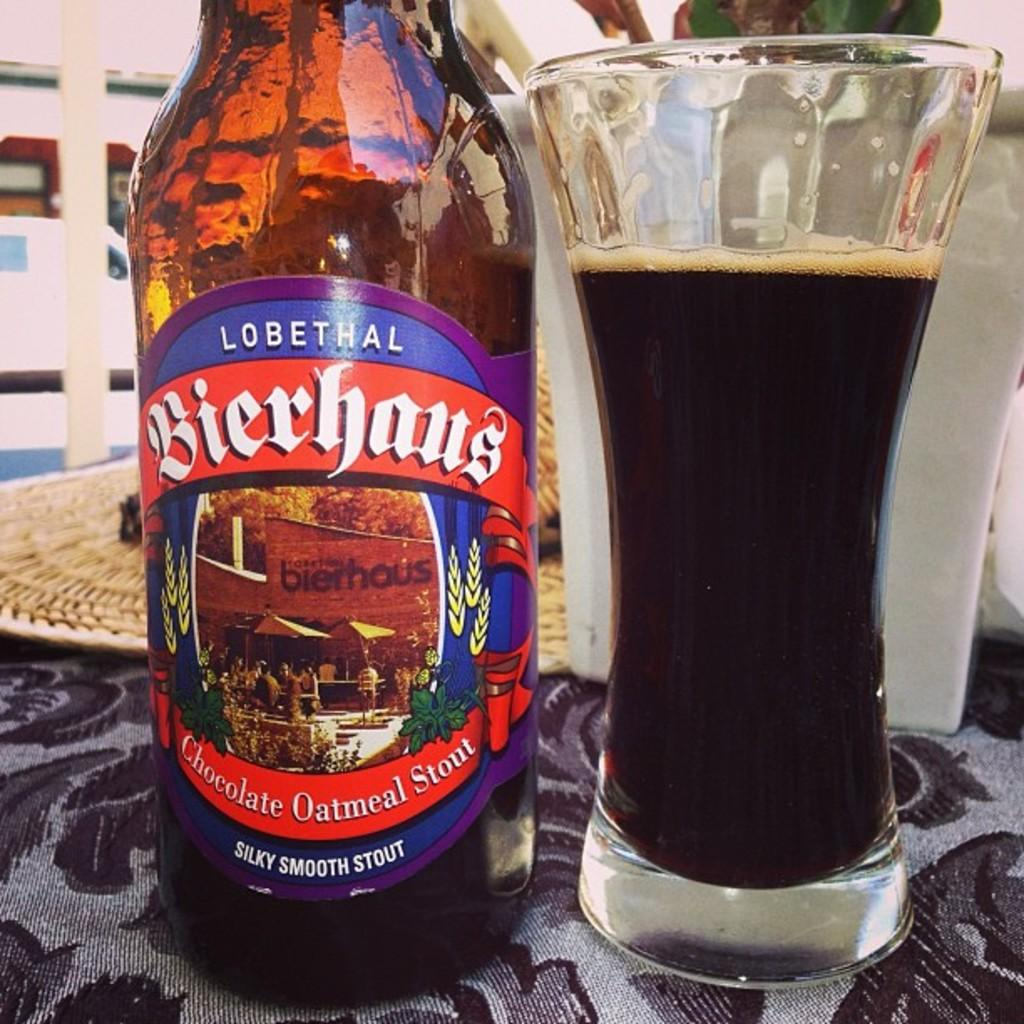Provide a one-sentence caption for the provided image. According to its label, a bottle of beer has a flavor of chocolate oatmeal stout. 